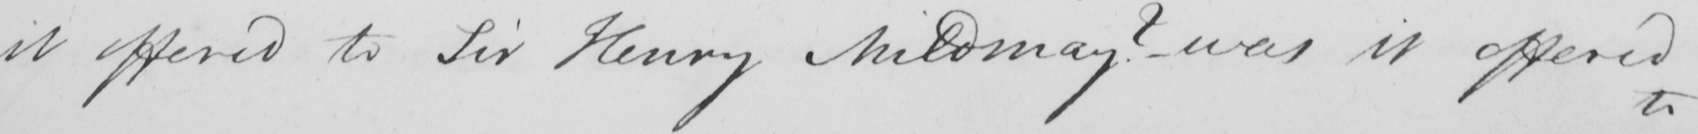Can you tell me what this handwritten text says? it offered to Sir Henry Mildmay ?   _  was it offered 